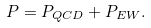<formula> <loc_0><loc_0><loc_500><loc_500>P = P _ { Q C D } + P _ { E W } .</formula> 